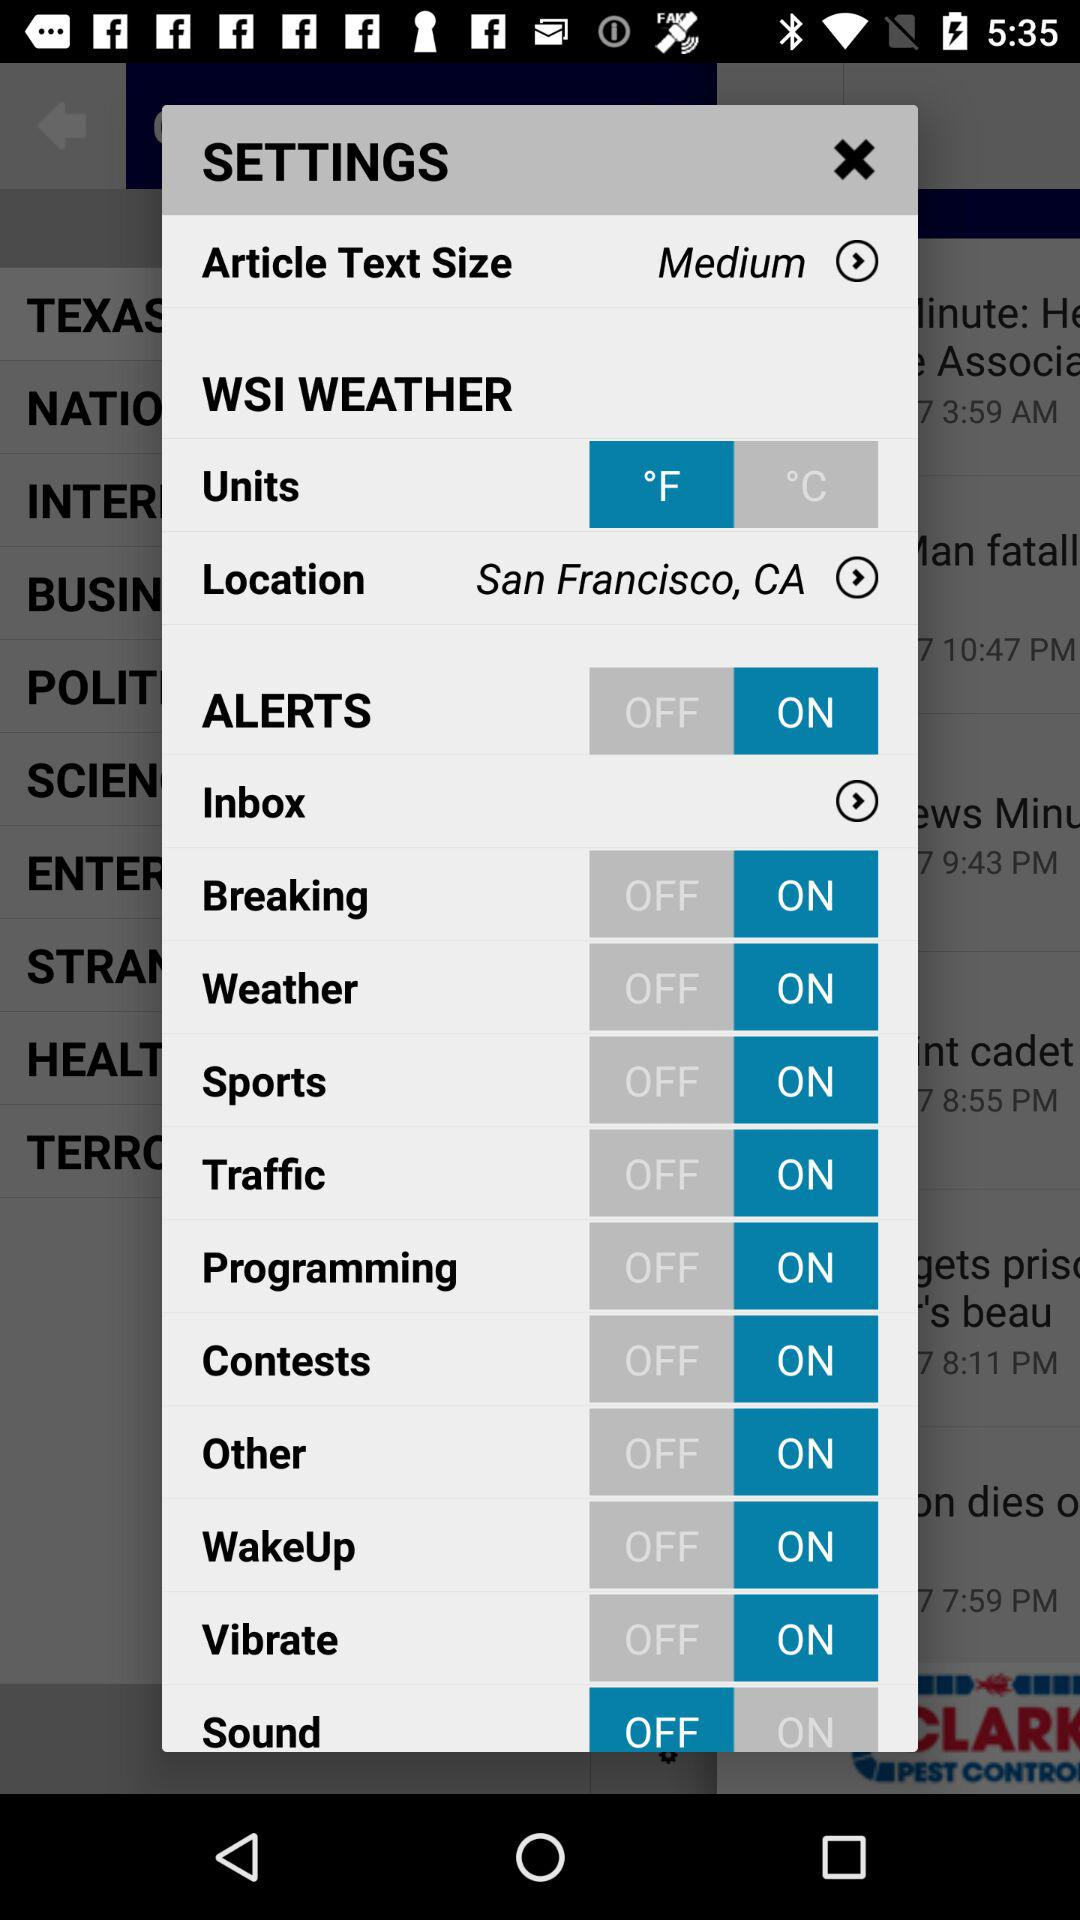What is the status of the "ALERTS" setting? The status is "on". 